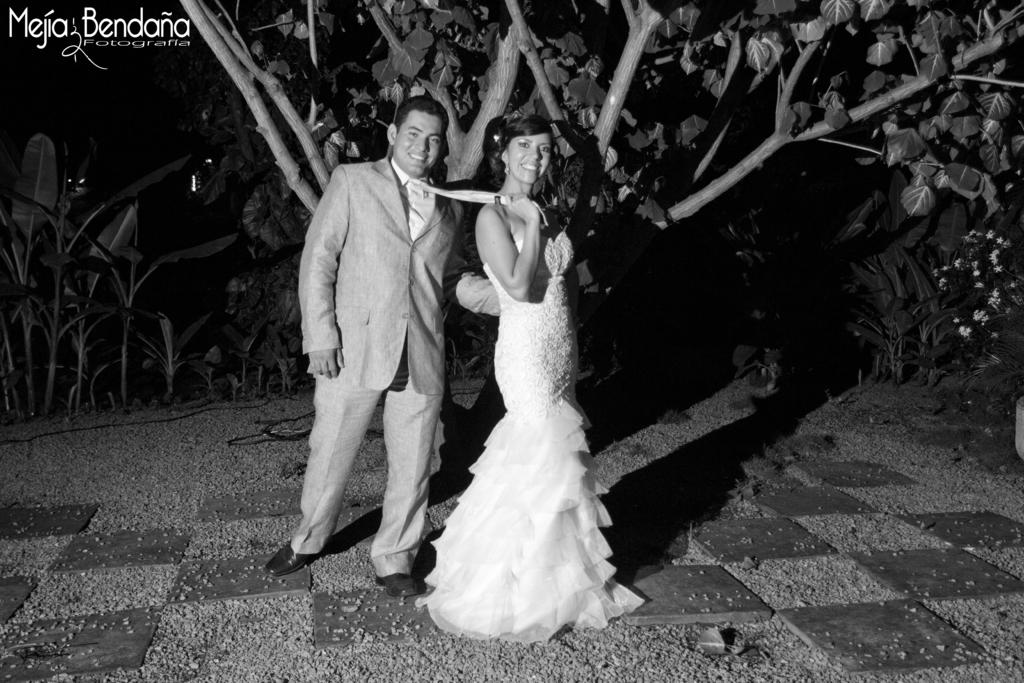How many people are in the image? There are two people in the image, a man and a woman. What are the man and woman doing in the image? Both the man and woman are standing, and they are smiling. What is the woman doing with the man's tie? The woman is holding the tie of the man. What can be seen in the background of the image? Trees are visible in the background of the image. Is there any indication of the image being altered or marked? Yes, there is a watermark on the image. Can you tell me how many bikes are visible in the image? There are no bikes visible in the image; it features a man and a woman standing and smiling. Is there a ghost present in the image? There is no ghost present in the image; it features a man and a woman standing and smiling. 